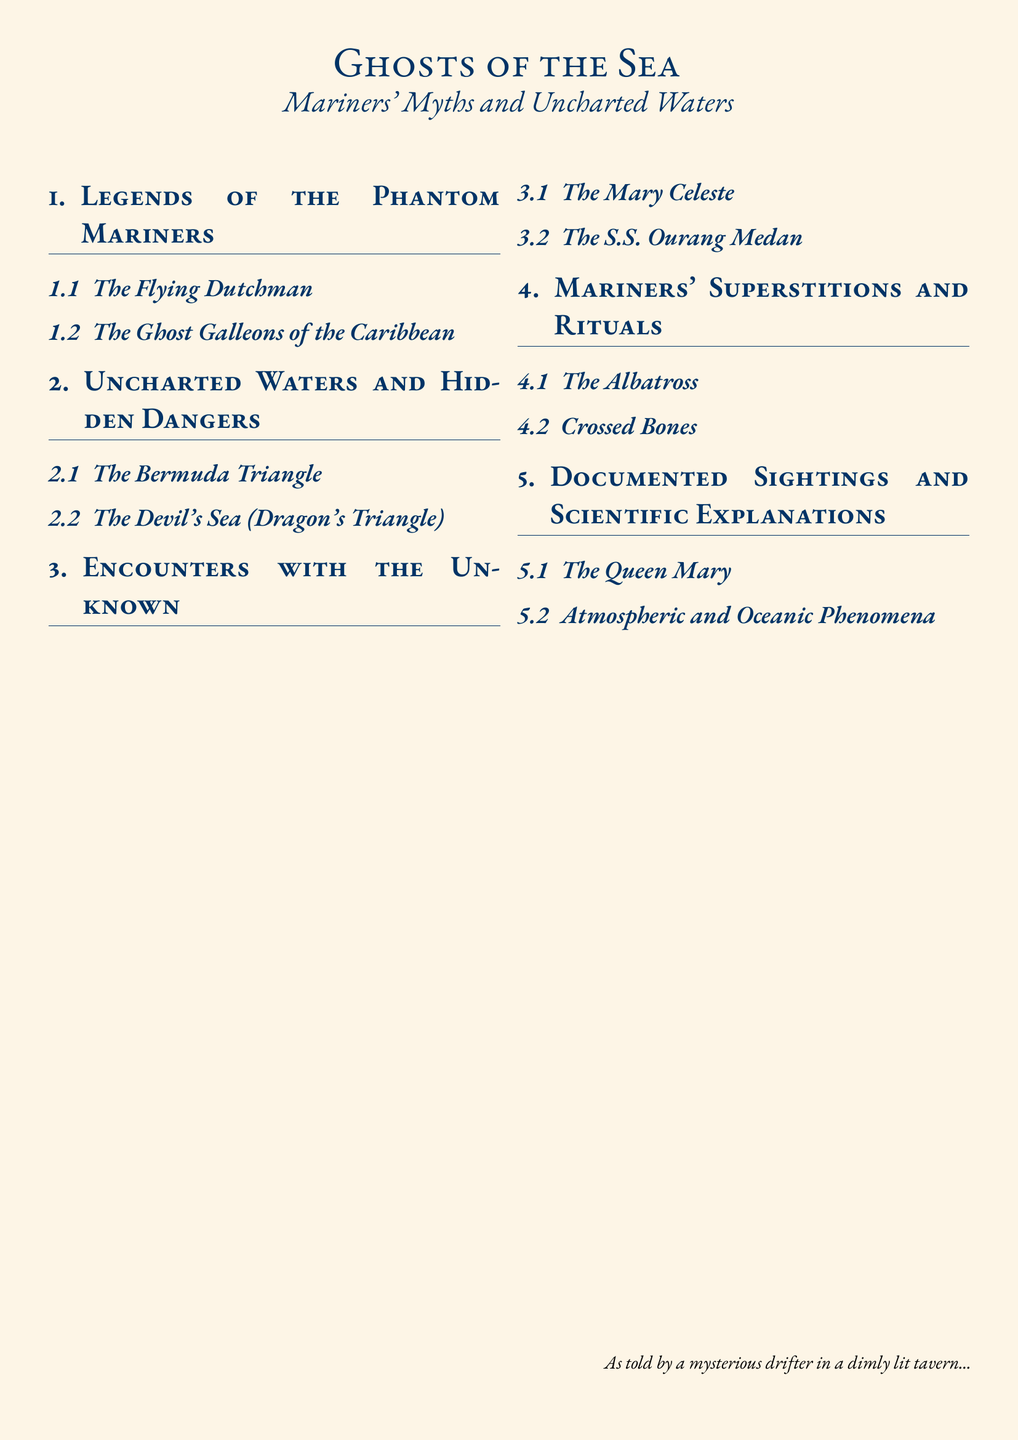What is the title of the document? The title is prominently displayed at the beginning of the document and identifies the main theme of the work.
Answer: Ghosts of the Sea How many sections are in the document? The number of sections can be counted in the structured layout of the document, notably under the main headings.
Answer: 5 What are the names of two ghost ships mentioned? The document specifies two particularly notable ghost ships in its content.
Answer: The Flying Dutchman, The Mary Celeste What phenomenon is associated with hidden dangers? The document addresses certain geographical areas reputed for mysterious occurrences, directly indicated in the section titles.
Answer: The Bermuda Triangle Which mariner superstition involves a bird? This superstition is included in the section dedicated to mariners' beliefs and rituals.
Answer: The Albatross What is the name of the ghost ship found in the Devil's Sea section? It is explicitly mentioned in the document regarding uncharted waters and hidden dangers.
Answer: The S.S. Ourang Medan How is the Queen Mary categorized in the document? The categorization reflects the type of subject matter discussed in its respective section.
Answer: Documented Sightings What is the color of the page background? The color is specified to provide an aesthetic quality to the document's overall appearance.
Answer: Lightsand What does the phrase "crossed bones" refer to? This phrase is mentioned in the context of mariner superstitions and rituals outlined in the document.
Answer: A superstition 